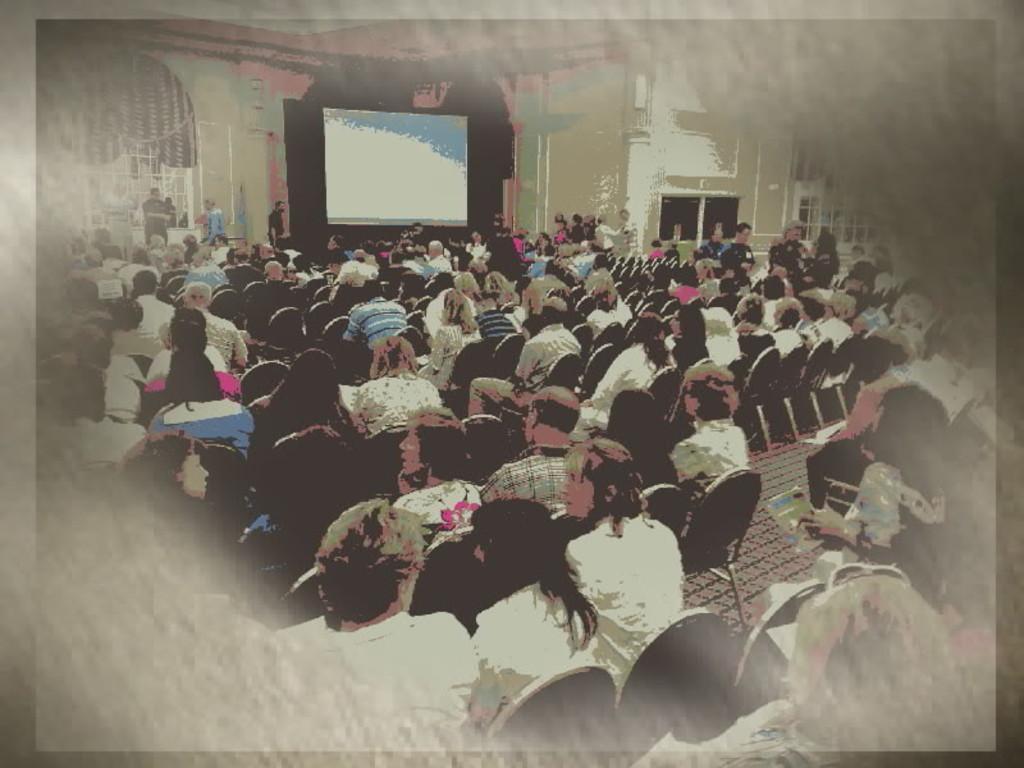Can you describe this image briefly? This is an edited image we can see people sitting on chairs, there are people, there are windows. And there is a screen on the wall in the background. 